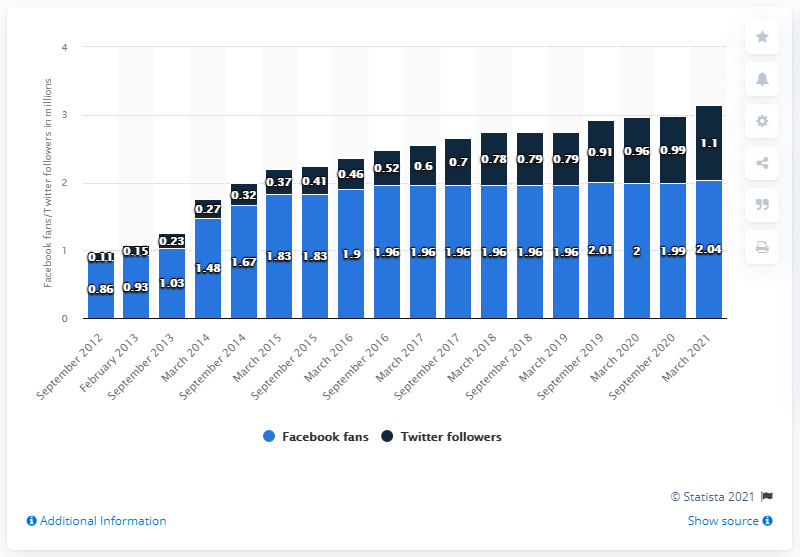Point out several critical features in this image. As of March 2018, the Denver Nuggets had a total of 2.74 followers. In March 2021, the Facebook page of the Denver Nuggets had a rating of 2.04. The number of followers reached its peak in March 2021. 